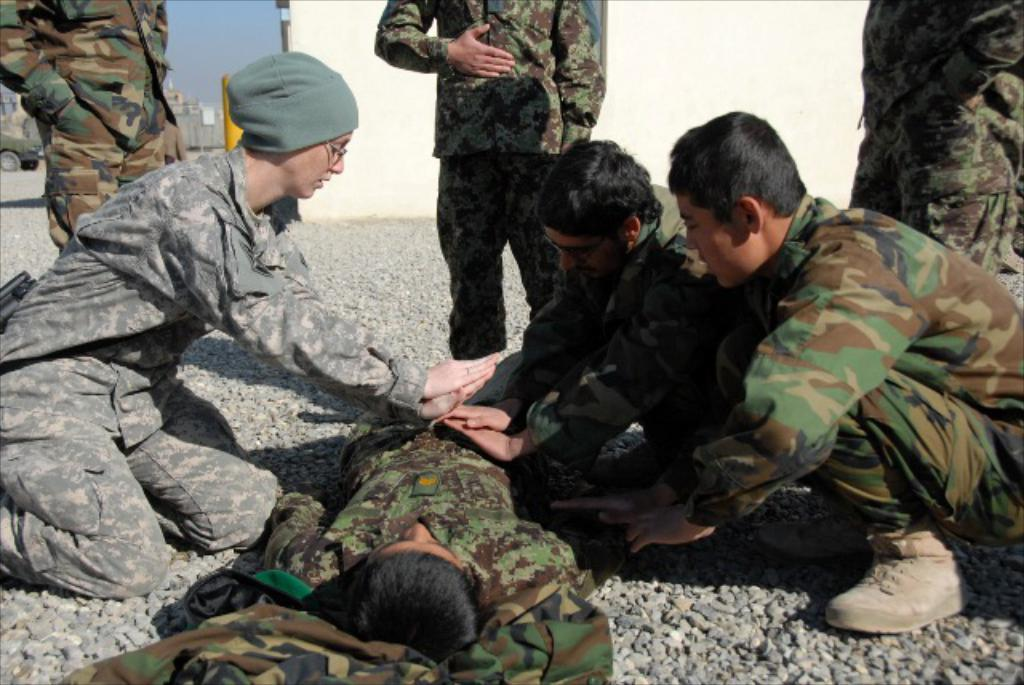What type of people can be seen in the image? There are military people in the image. What objects are present on the ground in the image? There are stones in the image. What can be seen in the background of the image? There is a wall, a vehicle, buildings, and the sky visible in the background of the image. What type of liquid is being poured by the military person in the image? There is no liquid being poured in the image; the military people are not performing any such action. 